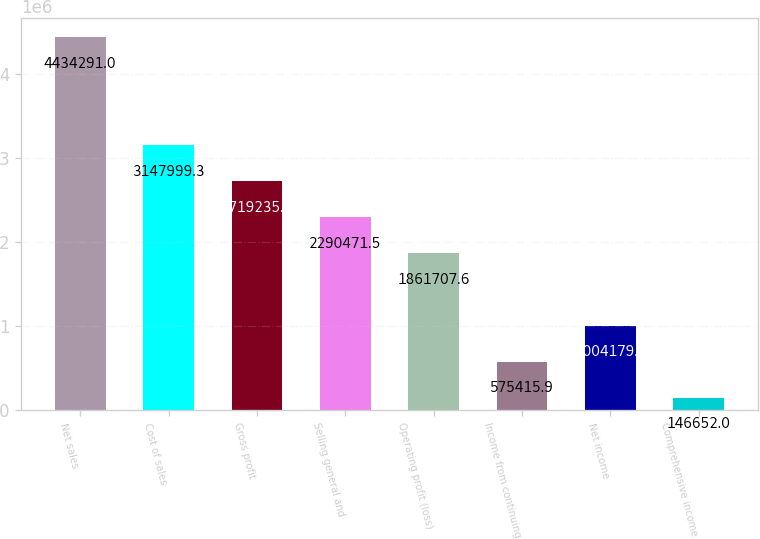Convert chart to OTSL. <chart><loc_0><loc_0><loc_500><loc_500><bar_chart><fcel>Net sales<fcel>Cost of sales<fcel>Gross profit<fcel>Selling general and<fcel>Operating profit (loss)<fcel>Income from continuing<fcel>Net income<fcel>Comprehensive income<nl><fcel>4.43429e+06<fcel>3.148e+06<fcel>2.71924e+06<fcel>2.29047e+06<fcel>1.86171e+06<fcel>575416<fcel>1.00418e+06<fcel>146652<nl></chart> 